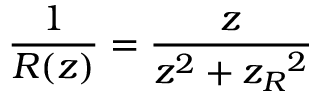<formula> <loc_0><loc_0><loc_500><loc_500>\frac { 1 } { R ( z ) } = \frac { z } { z ^ { 2 } + { z _ { R } } ^ { 2 } }</formula> 